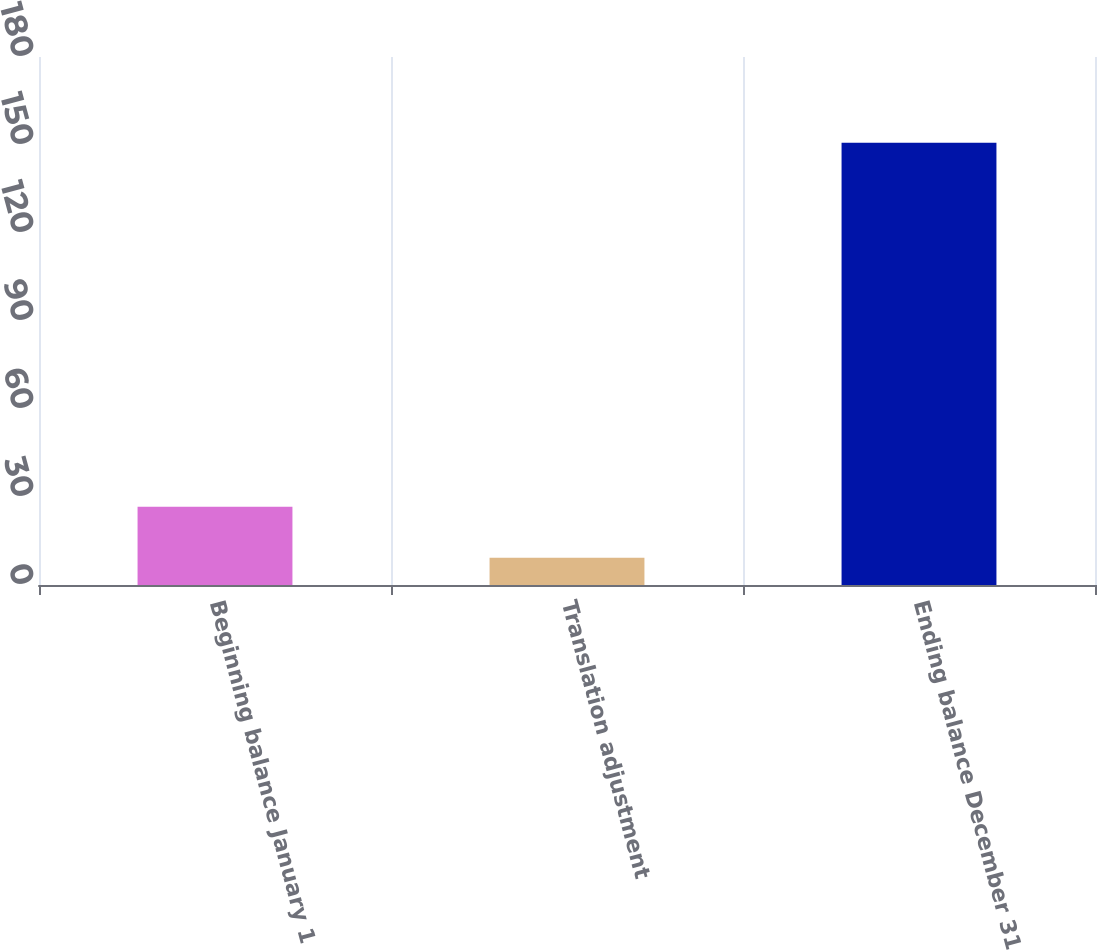Convert chart. <chart><loc_0><loc_0><loc_500><loc_500><bar_chart><fcel>Beginning balance January 1<fcel>Translation adjustment<fcel>Ending balance December 31<nl><fcel>26.7<fcel>9.3<fcel>150.8<nl></chart> 